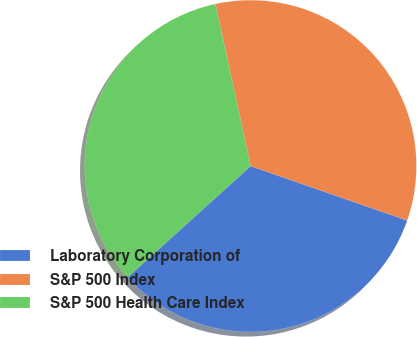<chart> <loc_0><loc_0><loc_500><loc_500><pie_chart><fcel>Laboratory Corporation of<fcel>S&P 500 Index<fcel>S&P 500 Health Care Index<nl><fcel>32.97%<fcel>33.73%<fcel>33.3%<nl></chart> 